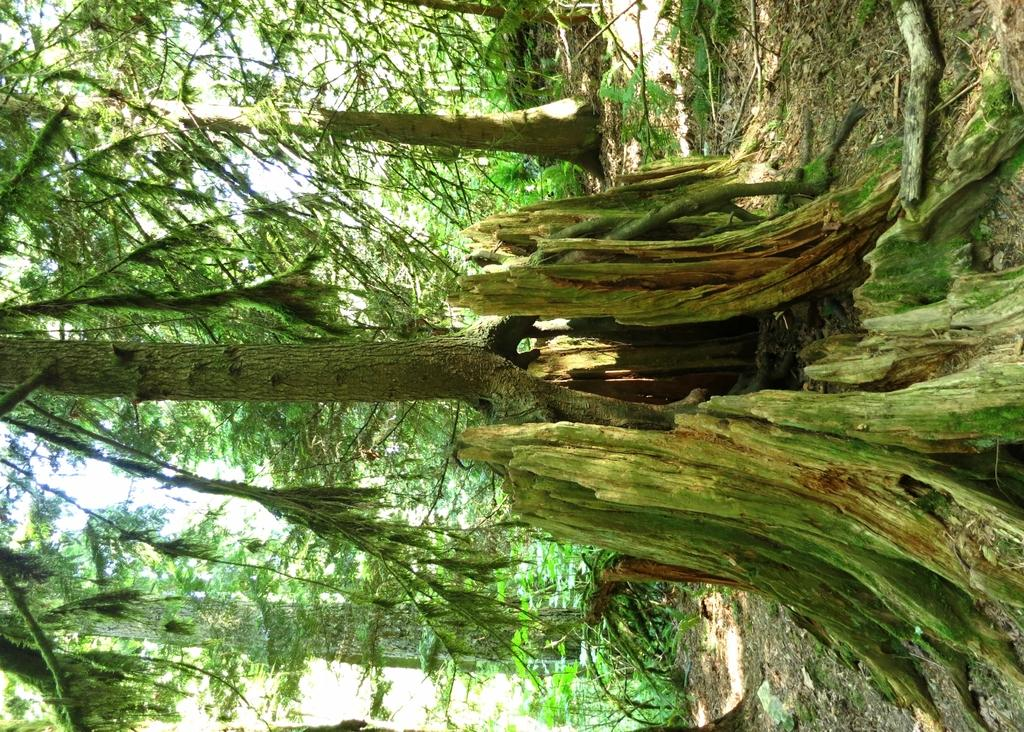What type of vegetation can be seen in the image? There are trees in the image. What type of necklace is hanging from the tree in the image? There is no necklace present in the image; it only features trees. What type of love can be seen expressed between the trees in the image? Trees do not express love, as they are inanimate objects. 